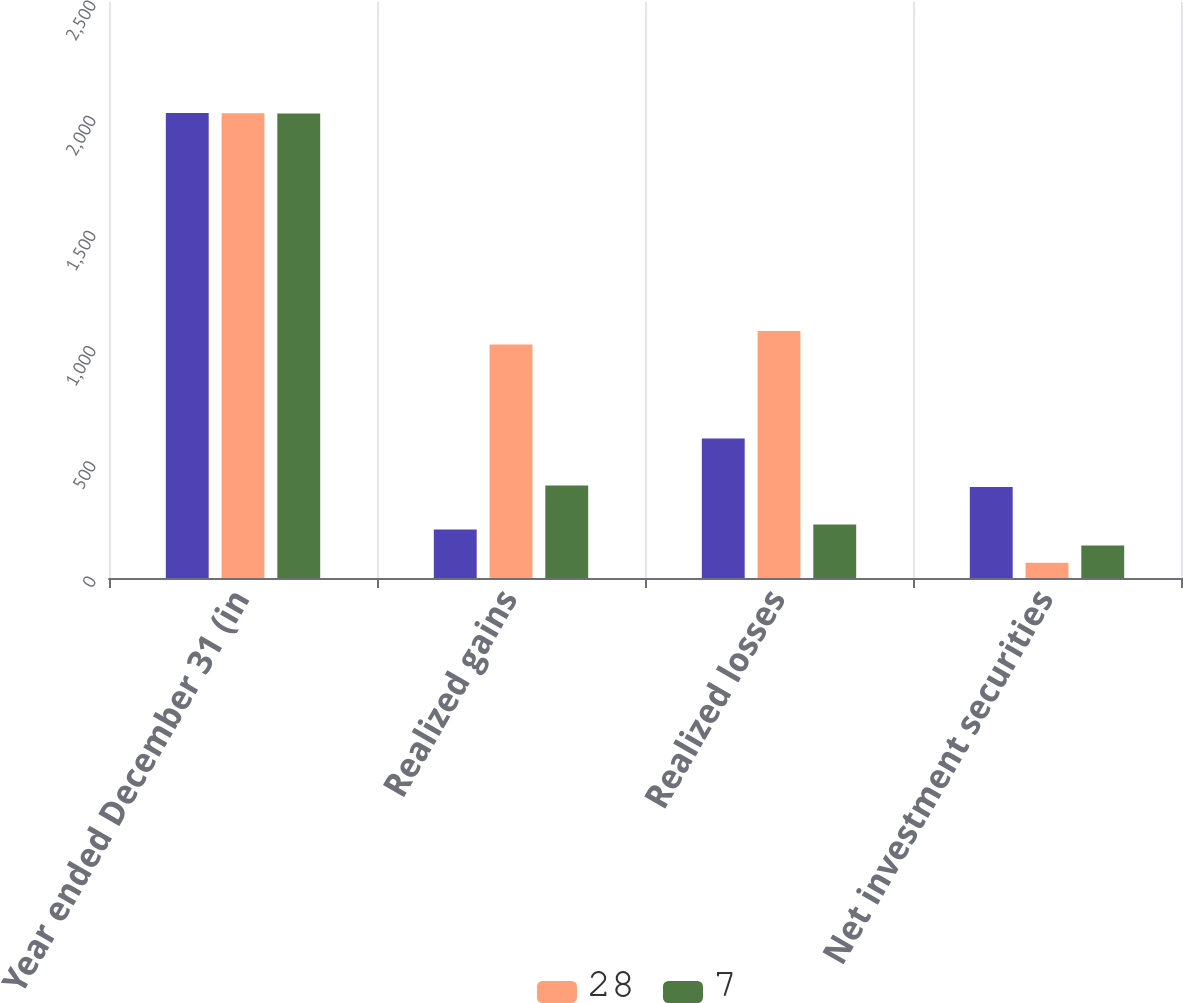Convert chart. <chart><loc_0><loc_0><loc_500><loc_500><stacked_bar_chart><ecel><fcel>Year ended December 31 (in<fcel>Realized gains<fcel>Realized losses<fcel>Net investment securities<nl><fcel>nan<fcel>2018<fcel>211<fcel>606<fcel>395<nl><fcel>28<fcel>2017<fcel>1013<fcel>1072<fcel>66<nl><fcel>7<fcel>2016<fcel>401<fcel>232<fcel>141<nl></chart> 